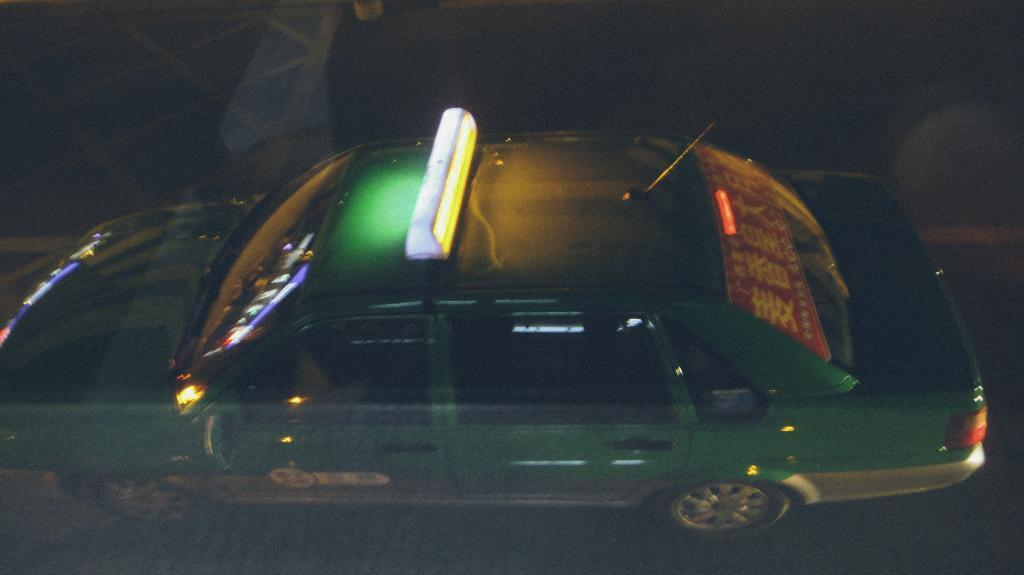What is the main subject of the image? There is a car in the image. What is the car doing in the image? The car is moving on the road. What color is the car? The car is green in color. What can be seen in the background of the image? The background of the image is black. When was the image taken? The image was taken in the dark. How much debt does the car have in the image? There is no information about the car's debt in the image. What type of paper is visible in the image? There is no paper present in the image. 